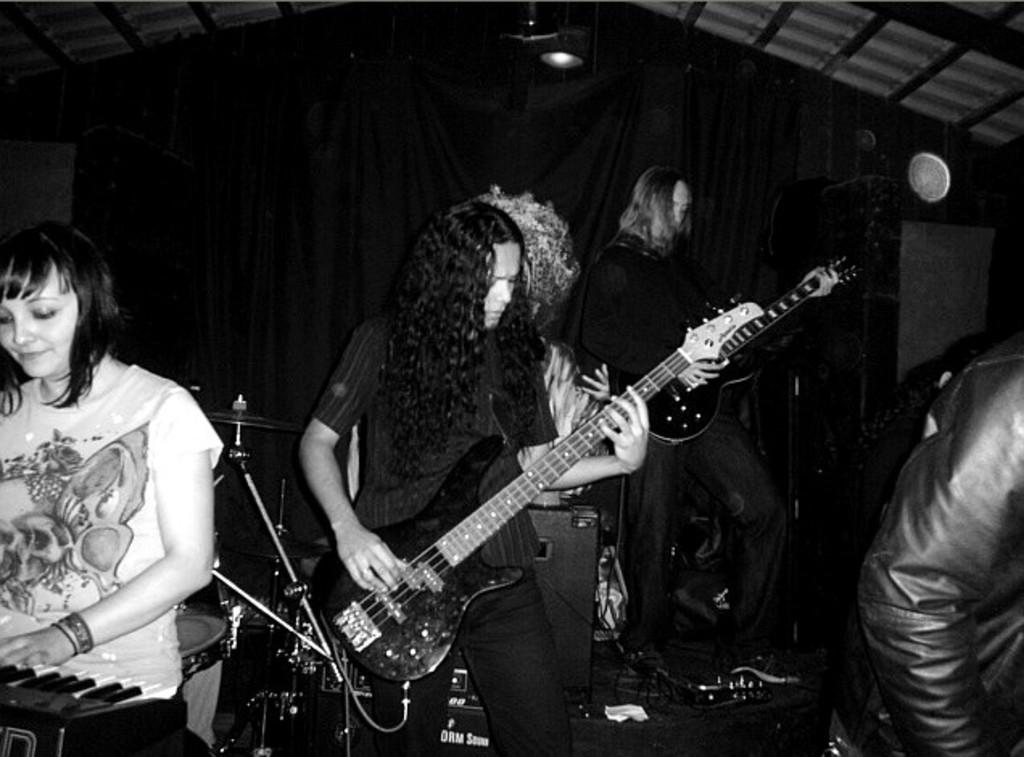What are the people in the image doing? The people in the image are playing musical instruments. What is located behind the people? There is a curtain behind the people. What can be seen at the top of the image? The top of the image includes a wall and a roof. Can you see a river flowing in the background of the image? There is no river visible in the image; it features people playing musical instruments with a curtain behind them and a wall and roof at the top. 